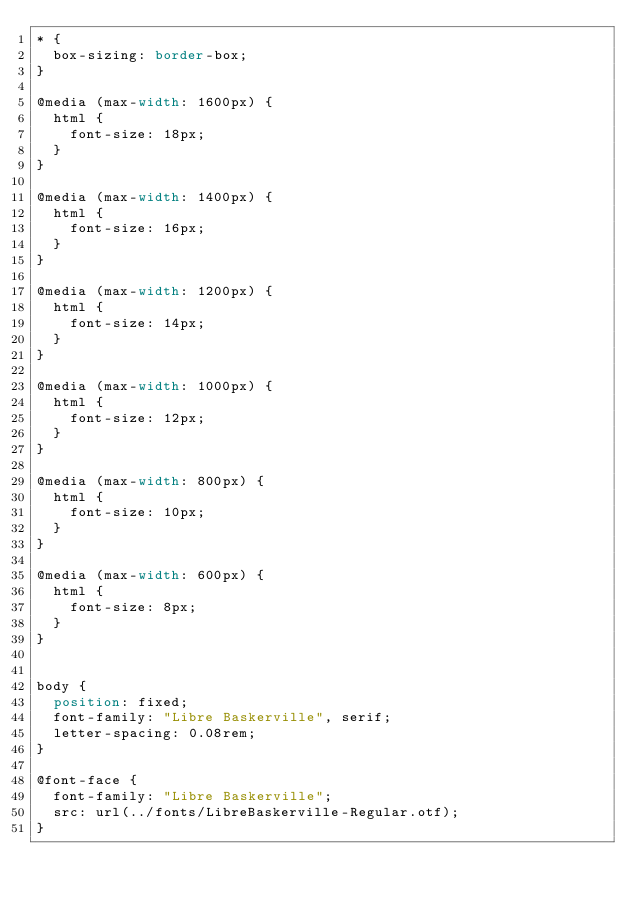<code> <loc_0><loc_0><loc_500><loc_500><_CSS_>* {
  box-sizing: border-box;
}

@media (max-width: 1600px) {
  html {
    font-size: 18px;
  }
}

@media (max-width: 1400px) {
  html {
    font-size: 16px;
  }
}

@media (max-width: 1200px) {
  html {
    font-size: 14px;
  }
}

@media (max-width: 1000px) {
  html {
    font-size: 12px;
  }
}

@media (max-width: 800px) {
  html {
    font-size: 10px;
  }
}

@media (max-width: 600px) {
  html {
    font-size: 8px;
  }
}


body {
  position: fixed;
  font-family: "Libre Baskerville", serif;
  letter-spacing: 0.08rem;
}

@font-face {
  font-family: "Libre Baskerville";
  src: url(../fonts/LibreBaskerville-Regular.otf);
}</code> 